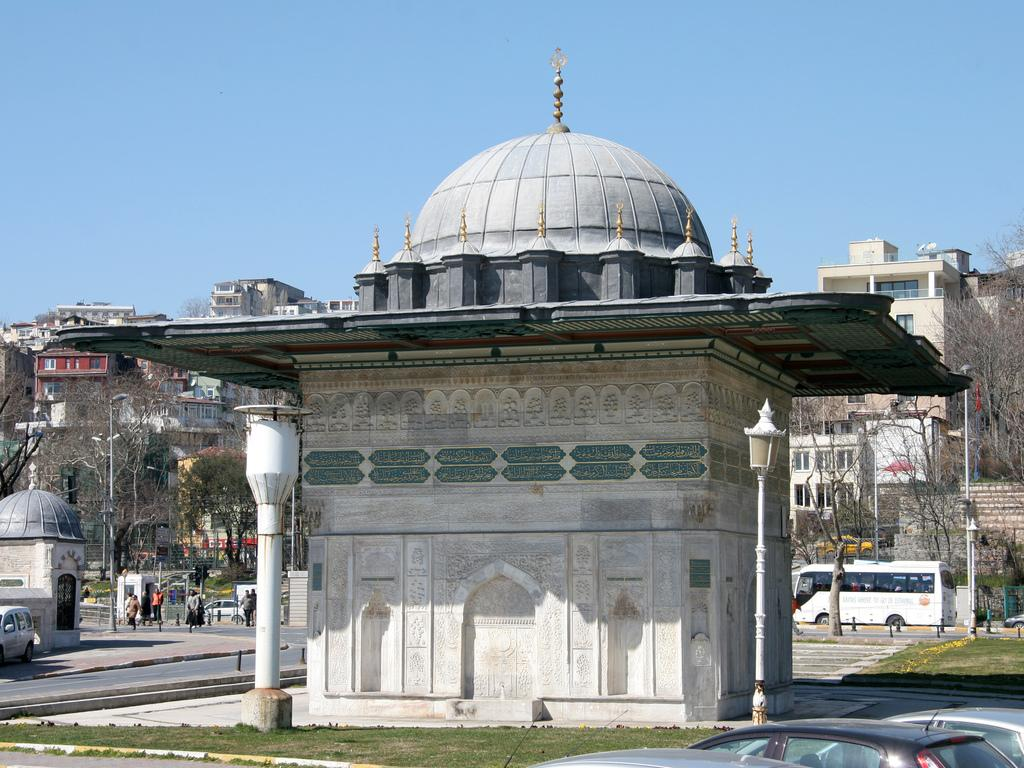What is happening on the road in the image? There are people and vehicles on the road in the image. What else can be seen in the image besides the road? Buildings, electric poles, trees, and some unspecified objects are visible in the image. What is visible in the background of the image? The sky is visible in the background of the image. How many passengers are on the act in the image? There is no act or passengers present in the image. What type of loss is depicted in the image? There is no loss depicted in the image; it features people, vehicles, buildings, electric poles, trees, unspecified objects, and the sky. 